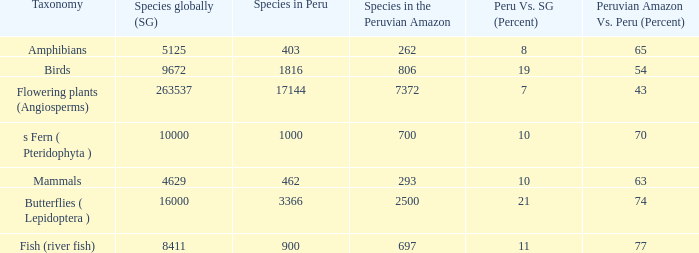What's the minimum species in the peruvian amazon with taxonomy s fern ( pteridophyta ) 700.0. 